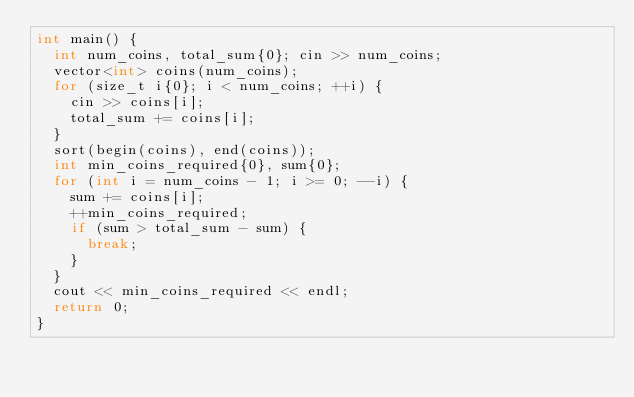<code> <loc_0><loc_0><loc_500><loc_500><_C++_>int main() {
  int num_coins, total_sum{0}; cin >> num_coins;
  vector<int> coins(num_coins);
  for (size_t i{0}; i < num_coins; ++i) {
    cin >> coins[i];
    total_sum += coins[i];
  }
  sort(begin(coins), end(coins));
  int min_coins_required{0}, sum{0};
  for (int i = num_coins - 1; i >= 0; --i) {
    sum += coins[i];
    ++min_coins_required;
    if (sum > total_sum - sum) {
      break;
    }
  }
  cout << min_coins_required << endl;
  return 0;
}
</code> 